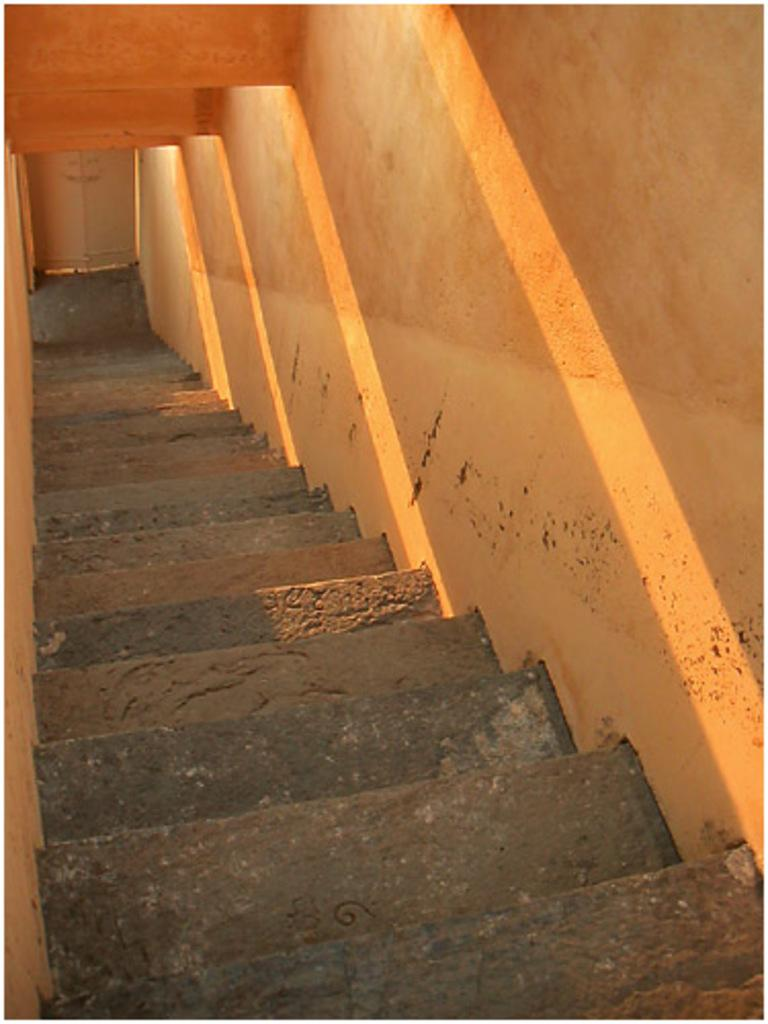What type of architectural feature is visible in the image? There are steps in the image. What surrounds the steps in the image? There are walls on the left and right sides of the image. What can be seen in the background of the image? There is a door in the background of the image. What color is the shirt worn by the person standing next to the door in the image? There is no person or shirt visible in the image; only steps, walls, and a door are present. 